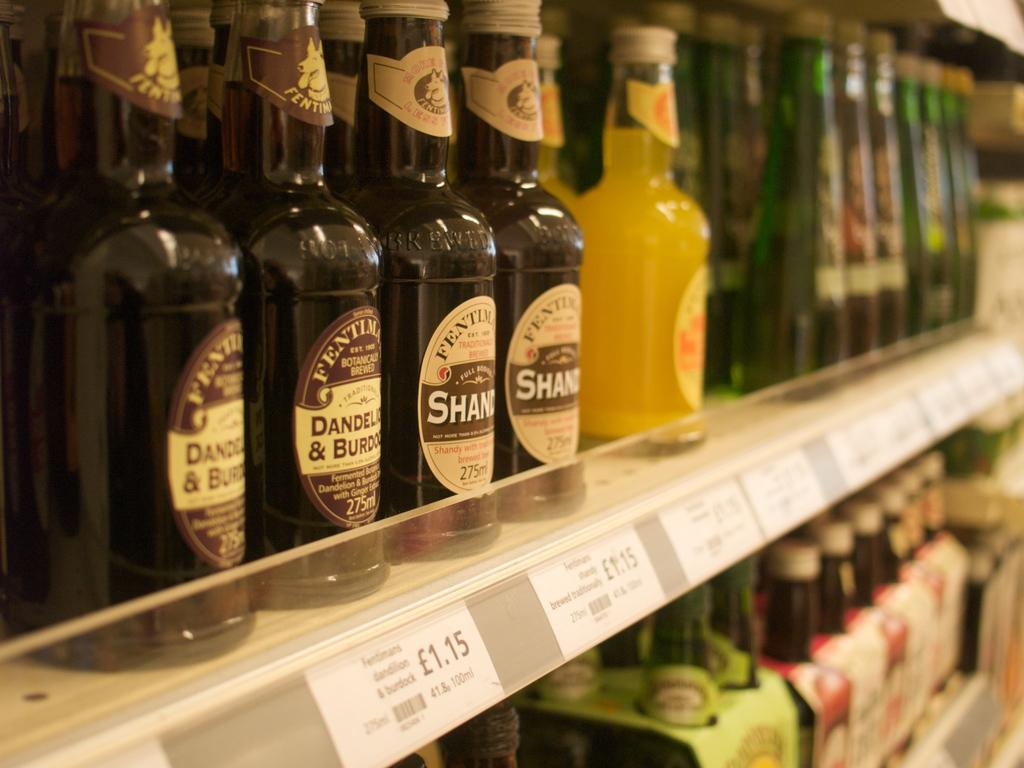<image>
Relay a brief, clear account of the picture shown. the word dandelion is on some different beer bottles 